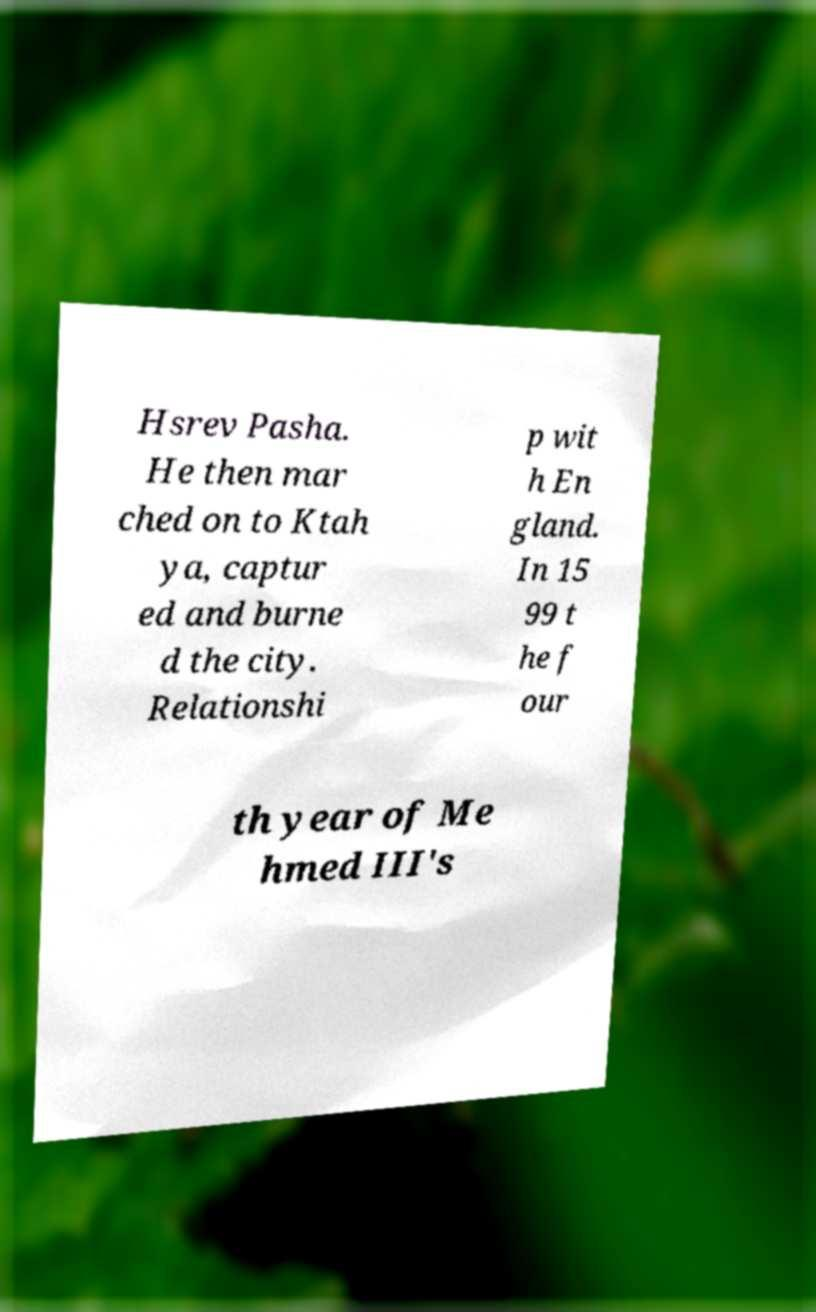I need the written content from this picture converted into text. Can you do that? Hsrev Pasha. He then mar ched on to Ktah ya, captur ed and burne d the city. Relationshi p wit h En gland. In 15 99 t he f our th year of Me hmed III's 